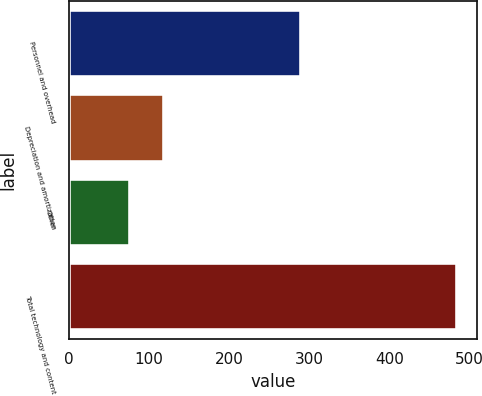Convert chart to OTSL. <chart><loc_0><loc_0><loc_500><loc_500><bar_chart><fcel>Personnel and overhead<fcel>Depreciation and amortization<fcel>Other<fcel>Total technology and content<nl><fcel>290<fcel>119<fcel>76<fcel>485<nl></chart> 